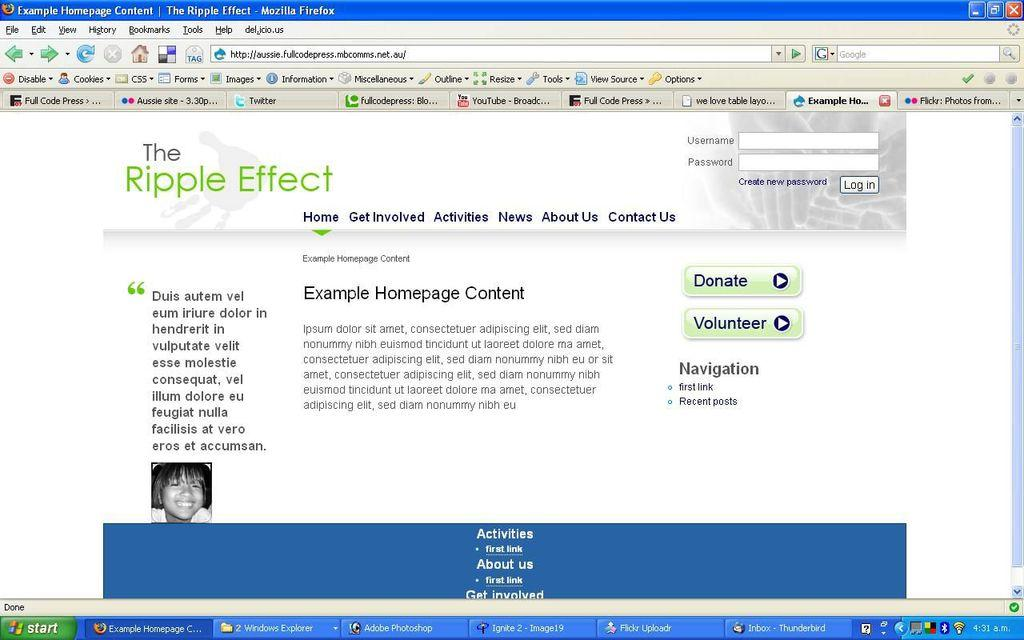<image>
Relay a brief, clear account of the picture shown. A windows computer has a webpage with the heading The Ripple Effect open. 